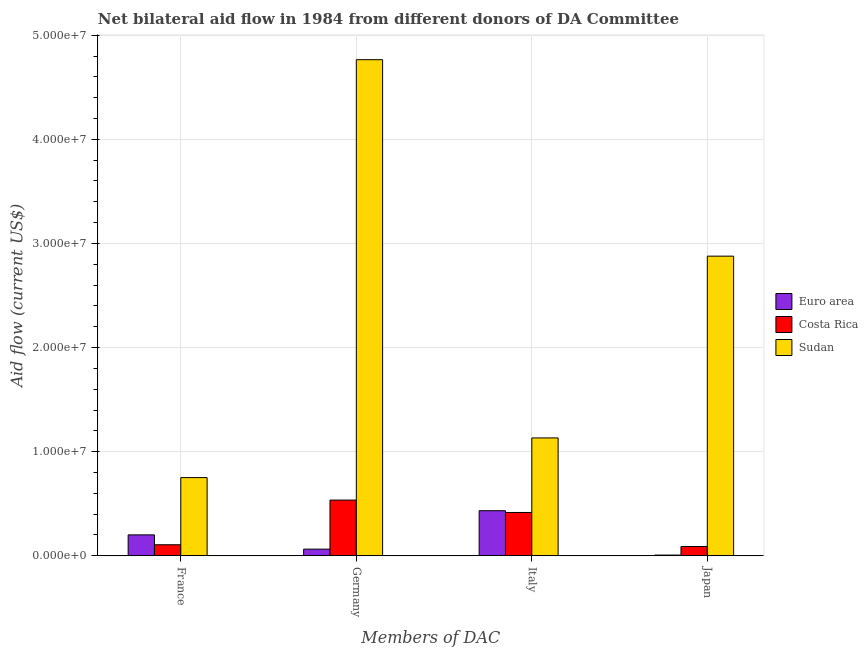How many different coloured bars are there?
Offer a very short reply. 3. How many groups of bars are there?
Provide a short and direct response. 4. How many bars are there on the 1st tick from the left?
Your answer should be very brief. 3. What is the label of the 3rd group of bars from the left?
Your response must be concise. Italy. What is the amount of aid given by italy in Euro area?
Your answer should be very brief. 4.33e+06. Across all countries, what is the maximum amount of aid given by france?
Your response must be concise. 7.51e+06. Across all countries, what is the minimum amount of aid given by germany?
Offer a terse response. 6.40e+05. In which country was the amount of aid given by italy maximum?
Provide a succinct answer. Sudan. What is the total amount of aid given by italy in the graph?
Provide a short and direct response. 1.98e+07. What is the difference between the amount of aid given by france in Euro area and that in Sudan?
Give a very brief answer. -5.50e+06. What is the difference between the amount of aid given by germany in Costa Rica and the amount of aid given by france in Euro area?
Offer a terse response. 3.34e+06. What is the average amount of aid given by france per country?
Provide a succinct answer. 3.53e+06. What is the difference between the amount of aid given by germany and amount of aid given by france in Costa Rica?
Your answer should be compact. 4.29e+06. What is the ratio of the amount of aid given by japan in Euro area to that in Costa Rica?
Offer a very short reply. 0.08. Is the amount of aid given by italy in Euro area less than that in Sudan?
Offer a terse response. Yes. What is the difference between the highest and the second highest amount of aid given by japan?
Give a very brief answer. 2.79e+07. What is the difference between the highest and the lowest amount of aid given by italy?
Make the answer very short. 7.16e+06. In how many countries, is the amount of aid given by italy greater than the average amount of aid given by italy taken over all countries?
Your answer should be compact. 1. Is it the case that in every country, the sum of the amount of aid given by japan and amount of aid given by italy is greater than the sum of amount of aid given by france and amount of aid given by germany?
Provide a short and direct response. No. What does the 2nd bar from the right in Japan represents?
Offer a terse response. Costa Rica. How many bars are there?
Make the answer very short. 12. What is the difference between two consecutive major ticks on the Y-axis?
Offer a terse response. 1.00e+07. Are the values on the major ticks of Y-axis written in scientific E-notation?
Provide a succinct answer. Yes. Does the graph contain grids?
Offer a very short reply. Yes. How are the legend labels stacked?
Provide a succinct answer. Vertical. What is the title of the graph?
Ensure brevity in your answer.  Net bilateral aid flow in 1984 from different donors of DA Committee. What is the label or title of the X-axis?
Your answer should be very brief. Members of DAC. What is the label or title of the Y-axis?
Offer a very short reply. Aid flow (current US$). What is the Aid flow (current US$) in Euro area in France?
Provide a short and direct response. 2.01e+06. What is the Aid flow (current US$) of Costa Rica in France?
Provide a short and direct response. 1.06e+06. What is the Aid flow (current US$) in Sudan in France?
Offer a very short reply. 7.51e+06. What is the Aid flow (current US$) in Euro area in Germany?
Provide a short and direct response. 6.40e+05. What is the Aid flow (current US$) in Costa Rica in Germany?
Your answer should be very brief. 5.35e+06. What is the Aid flow (current US$) of Sudan in Germany?
Offer a terse response. 4.76e+07. What is the Aid flow (current US$) of Euro area in Italy?
Provide a succinct answer. 4.33e+06. What is the Aid flow (current US$) of Costa Rica in Italy?
Make the answer very short. 4.16e+06. What is the Aid flow (current US$) of Sudan in Italy?
Offer a very short reply. 1.13e+07. What is the Aid flow (current US$) in Euro area in Japan?
Make the answer very short. 7.00e+04. What is the Aid flow (current US$) of Costa Rica in Japan?
Provide a short and direct response. 8.90e+05. What is the Aid flow (current US$) of Sudan in Japan?
Provide a succinct answer. 2.88e+07. Across all Members of DAC, what is the maximum Aid flow (current US$) of Euro area?
Give a very brief answer. 4.33e+06. Across all Members of DAC, what is the maximum Aid flow (current US$) of Costa Rica?
Your answer should be compact. 5.35e+06. Across all Members of DAC, what is the maximum Aid flow (current US$) of Sudan?
Offer a terse response. 4.76e+07. Across all Members of DAC, what is the minimum Aid flow (current US$) in Costa Rica?
Your answer should be very brief. 8.90e+05. Across all Members of DAC, what is the minimum Aid flow (current US$) in Sudan?
Make the answer very short. 7.51e+06. What is the total Aid flow (current US$) of Euro area in the graph?
Your answer should be very brief. 7.05e+06. What is the total Aid flow (current US$) in Costa Rica in the graph?
Your answer should be very brief. 1.15e+07. What is the total Aid flow (current US$) of Sudan in the graph?
Give a very brief answer. 9.53e+07. What is the difference between the Aid flow (current US$) in Euro area in France and that in Germany?
Your answer should be very brief. 1.37e+06. What is the difference between the Aid flow (current US$) of Costa Rica in France and that in Germany?
Provide a short and direct response. -4.29e+06. What is the difference between the Aid flow (current US$) of Sudan in France and that in Germany?
Give a very brief answer. -4.01e+07. What is the difference between the Aid flow (current US$) of Euro area in France and that in Italy?
Offer a terse response. -2.32e+06. What is the difference between the Aid flow (current US$) of Costa Rica in France and that in Italy?
Your response must be concise. -3.10e+06. What is the difference between the Aid flow (current US$) in Sudan in France and that in Italy?
Your answer should be very brief. -3.81e+06. What is the difference between the Aid flow (current US$) in Euro area in France and that in Japan?
Your response must be concise. 1.94e+06. What is the difference between the Aid flow (current US$) in Costa Rica in France and that in Japan?
Your answer should be compact. 1.70e+05. What is the difference between the Aid flow (current US$) in Sudan in France and that in Japan?
Make the answer very short. -2.13e+07. What is the difference between the Aid flow (current US$) in Euro area in Germany and that in Italy?
Make the answer very short. -3.69e+06. What is the difference between the Aid flow (current US$) in Costa Rica in Germany and that in Italy?
Your answer should be compact. 1.19e+06. What is the difference between the Aid flow (current US$) in Sudan in Germany and that in Italy?
Provide a short and direct response. 3.63e+07. What is the difference between the Aid flow (current US$) in Euro area in Germany and that in Japan?
Your answer should be very brief. 5.70e+05. What is the difference between the Aid flow (current US$) in Costa Rica in Germany and that in Japan?
Offer a terse response. 4.46e+06. What is the difference between the Aid flow (current US$) in Sudan in Germany and that in Japan?
Give a very brief answer. 1.89e+07. What is the difference between the Aid flow (current US$) of Euro area in Italy and that in Japan?
Keep it short and to the point. 4.26e+06. What is the difference between the Aid flow (current US$) of Costa Rica in Italy and that in Japan?
Your response must be concise. 3.27e+06. What is the difference between the Aid flow (current US$) in Sudan in Italy and that in Japan?
Offer a terse response. -1.75e+07. What is the difference between the Aid flow (current US$) in Euro area in France and the Aid flow (current US$) in Costa Rica in Germany?
Your answer should be compact. -3.34e+06. What is the difference between the Aid flow (current US$) in Euro area in France and the Aid flow (current US$) in Sudan in Germany?
Give a very brief answer. -4.56e+07. What is the difference between the Aid flow (current US$) of Costa Rica in France and the Aid flow (current US$) of Sudan in Germany?
Keep it short and to the point. -4.66e+07. What is the difference between the Aid flow (current US$) in Euro area in France and the Aid flow (current US$) in Costa Rica in Italy?
Provide a short and direct response. -2.15e+06. What is the difference between the Aid flow (current US$) of Euro area in France and the Aid flow (current US$) of Sudan in Italy?
Offer a terse response. -9.31e+06. What is the difference between the Aid flow (current US$) in Costa Rica in France and the Aid flow (current US$) in Sudan in Italy?
Make the answer very short. -1.03e+07. What is the difference between the Aid flow (current US$) in Euro area in France and the Aid flow (current US$) in Costa Rica in Japan?
Keep it short and to the point. 1.12e+06. What is the difference between the Aid flow (current US$) of Euro area in France and the Aid flow (current US$) of Sudan in Japan?
Ensure brevity in your answer.  -2.68e+07. What is the difference between the Aid flow (current US$) in Costa Rica in France and the Aid flow (current US$) in Sudan in Japan?
Provide a succinct answer. -2.77e+07. What is the difference between the Aid flow (current US$) of Euro area in Germany and the Aid flow (current US$) of Costa Rica in Italy?
Provide a short and direct response. -3.52e+06. What is the difference between the Aid flow (current US$) in Euro area in Germany and the Aid flow (current US$) in Sudan in Italy?
Keep it short and to the point. -1.07e+07. What is the difference between the Aid flow (current US$) in Costa Rica in Germany and the Aid flow (current US$) in Sudan in Italy?
Ensure brevity in your answer.  -5.97e+06. What is the difference between the Aid flow (current US$) of Euro area in Germany and the Aid flow (current US$) of Costa Rica in Japan?
Provide a succinct answer. -2.50e+05. What is the difference between the Aid flow (current US$) of Euro area in Germany and the Aid flow (current US$) of Sudan in Japan?
Your answer should be compact. -2.81e+07. What is the difference between the Aid flow (current US$) in Costa Rica in Germany and the Aid flow (current US$) in Sudan in Japan?
Give a very brief answer. -2.34e+07. What is the difference between the Aid flow (current US$) in Euro area in Italy and the Aid flow (current US$) in Costa Rica in Japan?
Offer a very short reply. 3.44e+06. What is the difference between the Aid flow (current US$) in Euro area in Italy and the Aid flow (current US$) in Sudan in Japan?
Ensure brevity in your answer.  -2.44e+07. What is the difference between the Aid flow (current US$) of Costa Rica in Italy and the Aid flow (current US$) of Sudan in Japan?
Provide a succinct answer. -2.46e+07. What is the average Aid flow (current US$) in Euro area per Members of DAC?
Offer a terse response. 1.76e+06. What is the average Aid flow (current US$) in Costa Rica per Members of DAC?
Your response must be concise. 2.86e+06. What is the average Aid flow (current US$) of Sudan per Members of DAC?
Offer a very short reply. 2.38e+07. What is the difference between the Aid flow (current US$) of Euro area and Aid flow (current US$) of Costa Rica in France?
Provide a succinct answer. 9.50e+05. What is the difference between the Aid flow (current US$) in Euro area and Aid flow (current US$) in Sudan in France?
Ensure brevity in your answer.  -5.50e+06. What is the difference between the Aid flow (current US$) of Costa Rica and Aid flow (current US$) of Sudan in France?
Your answer should be very brief. -6.45e+06. What is the difference between the Aid flow (current US$) in Euro area and Aid flow (current US$) in Costa Rica in Germany?
Ensure brevity in your answer.  -4.71e+06. What is the difference between the Aid flow (current US$) of Euro area and Aid flow (current US$) of Sudan in Germany?
Ensure brevity in your answer.  -4.70e+07. What is the difference between the Aid flow (current US$) in Costa Rica and Aid flow (current US$) in Sudan in Germany?
Give a very brief answer. -4.23e+07. What is the difference between the Aid flow (current US$) of Euro area and Aid flow (current US$) of Costa Rica in Italy?
Provide a short and direct response. 1.70e+05. What is the difference between the Aid flow (current US$) of Euro area and Aid flow (current US$) of Sudan in Italy?
Offer a terse response. -6.99e+06. What is the difference between the Aid flow (current US$) in Costa Rica and Aid flow (current US$) in Sudan in Italy?
Give a very brief answer. -7.16e+06. What is the difference between the Aid flow (current US$) in Euro area and Aid flow (current US$) in Costa Rica in Japan?
Your response must be concise. -8.20e+05. What is the difference between the Aid flow (current US$) of Euro area and Aid flow (current US$) of Sudan in Japan?
Offer a very short reply. -2.87e+07. What is the difference between the Aid flow (current US$) of Costa Rica and Aid flow (current US$) of Sudan in Japan?
Make the answer very short. -2.79e+07. What is the ratio of the Aid flow (current US$) of Euro area in France to that in Germany?
Offer a very short reply. 3.14. What is the ratio of the Aid flow (current US$) of Costa Rica in France to that in Germany?
Your answer should be very brief. 0.2. What is the ratio of the Aid flow (current US$) of Sudan in France to that in Germany?
Provide a short and direct response. 0.16. What is the ratio of the Aid flow (current US$) in Euro area in France to that in Italy?
Offer a very short reply. 0.46. What is the ratio of the Aid flow (current US$) of Costa Rica in France to that in Italy?
Provide a succinct answer. 0.25. What is the ratio of the Aid flow (current US$) in Sudan in France to that in Italy?
Provide a short and direct response. 0.66. What is the ratio of the Aid flow (current US$) of Euro area in France to that in Japan?
Provide a short and direct response. 28.71. What is the ratio of the Aid flow (current US$) in Costa Rica in France to that in Japan?
Make the answer very short. 1.19. What is the ratio of the Aid flow (current US$) in Sudan in France to that in Japan?
Your answer should be very brief. 0.26. What is the ratio of the Aid flow (current US$) of Euro area in Germany to that in Italy?
Offer a very short reply. 0.15. What is the ratio of the Aid flow (current US$) of Costa Rica in Germany to that in Italy?
Give a very brief answer. 1.29. What is the ratio of the Aid flow (current US$) of Sudan in Germany to that in Italy?
Keep it short and to the point. 4.21. What is the ratio of the Aid flow (current US$) in Euro area in Germany to that in Japan?
Provide a short and direct response. 9.14. What is the ratio of the Aid flow (current US$) of Costa Rica in Germany to that in Japan?
Your response must be concise. 6.01. What is the ratio of the Aid flow (current US$) of Sudan in Germany to that in Japan?
Provide a succinct answer. 1.66. What is the ratio of the Aid flow (current US$) of Euro area in Italy to that in Japan?
Provide a succinct answer. 61.86. What is the ratio of the Aid flow (current US$) in Costa Rica in Italy to that in Japan?
Your response must be concise. 4.67. What is the ratio of the Aid flow (current US$) in Sudan in Italy to that in Japan?
Your response must be concise. 0.39. What is the difference between the highest and the second highest Aid flow (current US$) of Euro area?
Offer a terse response. 2.32e+06. What is the difference between the highest and the second highest Aid flow (current US$) in Costa Rica?
Ensure brevity in your answer.  1.19e+06. What is the difference between the highest and the second highest Aid flow (current US$) of Sudan?
Offer a very short reply. 1.89e+07. What is the difference between the highest and the lowest Aid flow (current US$) in Euro area?
Offer a very short reply. 4.26e+06. What is the difference between the highest and the lowest Aid flow (current US$) in Costa Rica?
Offer a very short reply. 4.46e+06. What is the difference between the highest and the lowest Aid flow (current US$) in Sudan?
Ensure brevity in your answer.  4.01e+07. 